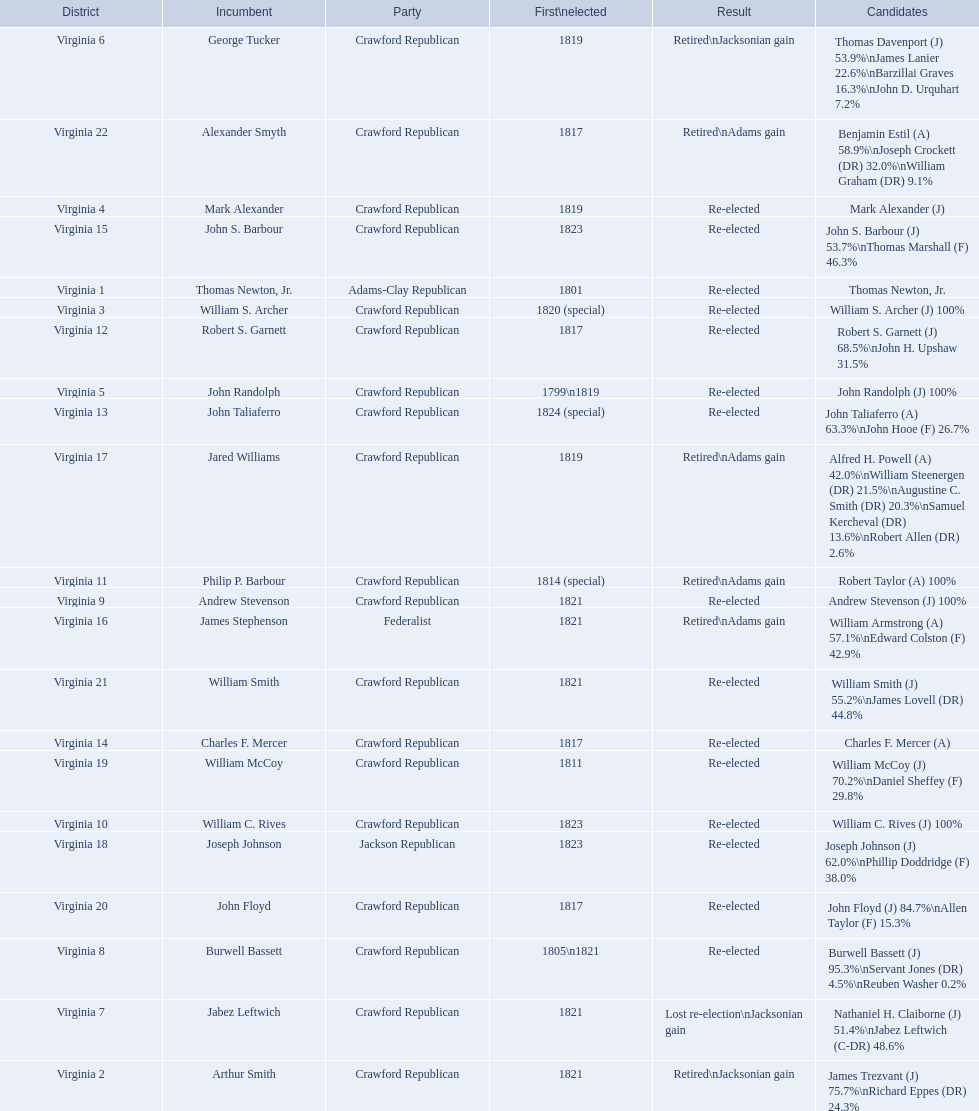What party is a crawford republican? Crawford Republican, Crawford Republican, Crawford Republican, Crawford Republican, Crawford Republican, Crawford Republican, Crawford Republican, Crawford Republican, Crawford Republican, Crawford Republican, Crawford Republican, Crawford Republican, Crawford Republican, Crawford Republican, Crawford Republican, Crawford Republican, Crawford Republican, Crawford Republican, Crawford Republican. Would you be able to parse every entry in this table? {'header': ['District', 'Incumbent', 'Party', 'First\\nelected', 'Result', 'Candidates'], 'rows': [['Virginia 6', 'George Tucker', 'Crawford Republican', '1819', 'Retired\\nJacksonian gain', 'Thomas Davenport (J) 53.9%\\nJames Lanier 22.6%\\nBarzillai Graves 16.3%\\nJohn D. Urquhart 7.2%'], ['Virginia 22', 'Alexander Smyth', 'Crawford Republican', '1817', 'Retired\\nAdams gain', 'Benjamin Estil (A) 58.9%\\nJoseph Crockett (DR) 32.0%\\nWilliam Graham (DR) 9.1%'], ['Virginia 4', 'Mark Alexander', 'Crawford Republican', '1819', 'Re-elected', 'Mark Alexander (J)'], ['Virginia 15', 'John S. Barbour', 'Crawford Republican', '1823', 'Re-elected', 'John S. Barbour (J) 53.7%\\nThomas Marshall (F) 46.3%'], ['Virginia 1', 'Thomas Newton, Jr.', 'Adams-Clay Republican', '1801', 'Re-elected', 'Thomas Newton, Jr.'], ['Virginia 3', 'William S. Archer', 'Crawford Republican', '1820 (special)', 'Re-elected', 'William S. Archer (J) 100%'], ['Virginia 12', 'Robert S. Garnett', 'Crawford Republican', '1817', 'Re-elected', 'Robert S. Garnett (J) 68.5%\\nJohn H. Upshaw 31.5%'], ['Virginia 5', 'John Randolph', 'Crawford Republican', '1799\\n1819', 'Re-elected', 'John Randolph (J) 100%'], ['Virginia 13', 'John Taliaferro', 'Crawford Republican', '1824 (special)', 'Re-elected', 'John Taliaferro (A) 63.3%\\nJohn Hooe (F) 26.7%'], ['Virginia 17', 'Jared Williams', 'Crawford Republican', '1819', 'Retired\\nAdams gain', 'Alfred H. Powell (A) 42.0%\\nWilliam Steenergen (DR) 21.5%\\nAugustine C. Smith (DR) 20.3%\\nSamuel Kercheval (DR) 13.6%\\nRobert Allen (DR) 2.6%'], ['Virginia 11', 'Philip P. Barbour', 'Crawford Republican', '1814 (special)', 'Retired\\nAdams gain', 'Robert Taylor (A) 100%'], ['Virginia 9', 'Andrew Stevenson', 'Crawford Republican', '1821', 'Re-elected', 'Andrew Stevenson (J) 100%'], ['Virginia 16', 'James Stephenson', 'Federalist', '1821', 'Retired\\nAdams gain', 'William Armstrong (A) 57.1%\\nEdward Colston (F) 42.9%'], ['Virginia 21', 'William Smith', 'Crawford Republican', '1821', 'Re-elected', 'William Smith (J) 55.2%\\nJames Lovell (DR) 44.8%'], ['Virginia 14', 'Charles F. Mercer', 'Crawford Republican', '1817', 'Re-elected', 'Charles F. Mercer (A)'], ['Virginia 19', 'William McCoy', 'Crawford Republican', '1811', 'Re-elected', 'William McCoy (J) 70.2%\\nDaniel Sheffey (F) 29.8%'], ['Virginia 10', 'William C. Rives', 'Crawford Republican', '1823', 'Re-elected', 'William C. Rives (J) 100%'], ['Virginia 18', 'Joseph Johnson', 'Jackson Republican', '1823', 'Re-elected', 'Joseph Johnson (J) 62.0%\\nPhillip Doddridge (F) 38.0%'], ['Virginia 20', 'John Floyd', 'Crawford Republican', '1817', 'Re-elected', 'John Floyd (J) 84.7%\\nAllen Taylor (F) 15.3%'], ['Virginia 8', 'Burwell Bassett', 'Crawford Republican', '1805\\n1821', 'Re-elected', 'Burwell Bassett (J) 95.3%\\nServant Jones (DR) 4.5%\\nReuben Washer 0.2%'], ['Virginia 7', 'Jabez Leftwich', 'Crawford Republican', '1821', 'Lost re-election\\nJacksonian gain', 'Nathaniel H. Claiborne (J) 51.4%\\nJabez Leftwich (C-DR) 48.6%'], ['Virginia 2', 'Arthur Smith', 'Crawford Republican', '1821', 'Retired\\nJacksonian gain', 'James Trezvant (J) 75.7%\\nRichard Eppes (DR) 24.3%']]} What candidates have over 76%? James Trezvant (J) 75.7%\nRichard Eppes (DR) 24.3%, William S. Archer (J) 100%, John Randolph (J) 100%, Burwell Bassett (J) 95.3%\nServant Jones (DR) 4.5%\nReuben Washer 0.2%, Andrew Stevenson (J) 100%, William C. Rives (J) 100%, Robert Taylor (A) 100%, John Floyd (J) 84.7%\nAllen Taylor (F) 15.3%. Which result was retired jacksonian gain? Retired\nJacksonian gain. Who was the incumbent? Arthur Smith. 